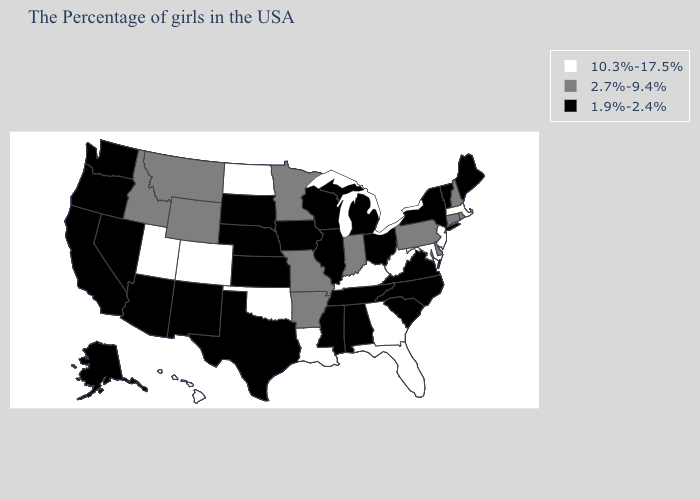Which states hav the highest value in the Northeast?
Quick response, please. Massachusetts, New Jersey. Does Pennsylvania have the highest value in the USA?
Write a very short answer. No. What is the value of New Jersey?
Be succinct. 10.3%-17.5%. What is the value of Hawaii?
Write a very short answer. 10.3%-17.5%. Name the states that have a value in the range 1.9%-2.4%?
Concise answer only. Maine, Vermont, New York, Virginia, North Carolina, South Carolina, Ohio, Michigan, Alabama, Tennessee, Wisconsin, Illinois, Mississippi, Iowa, Kansas, Nebraska, Texas, South Dakota, New Mexico, Arizona, Nevada, California, Washington, Oregon, Alaska. Name the states that have a value in the range 1.9%-2.4%?
Keep it brief. Maine, Vermont, New York, Virginia, North Carolina, South Carolina, Ohio, Michigan, Alabama, Tennessee, Wisconsin, Illinois, Mississippi, Iowa, Kansas, Nebraska, Texas, South Dakota, New Mexico, Arizona, Nevada, California, Washington, Oregon, Alaska. Does Florida have the lowest value in the USA?
Answer briefly. No. Among the states that border Oklahoma , does Colorado have the highest value?
Be succinct. Yes. Name the states that have a value in the range 10.3%-17.5%?
Be succinct. Massachusetts, New Jersey, Maryland, West Virginia, Florida, Georgia, Kentucky, Louisiana, Oklahoma, North Dakota, Colorado, Utah, Hawaii. Does the map have missing data?
Short answer required. No. Name the states that have a value in the range 10.3%-17.5%?
Be succinct. Massachusetts, New Jersey, Maryland, West Virginia, Florida, Georgia, Kentucky, Louisiana, Oklahoma, North Dakota, Colorado, Utah, Hawaii. Does North Dakota have a lower value than Michigan?
Keep it brief. No. Does Texas have the lowest value in the USA?
Quick response, please. Yes. What is the lowest value in the Northeast?
Answer briefly. 1.9%-2.4%. Does Georgia have the highest value in the South?
Keep it brief. Yes. 